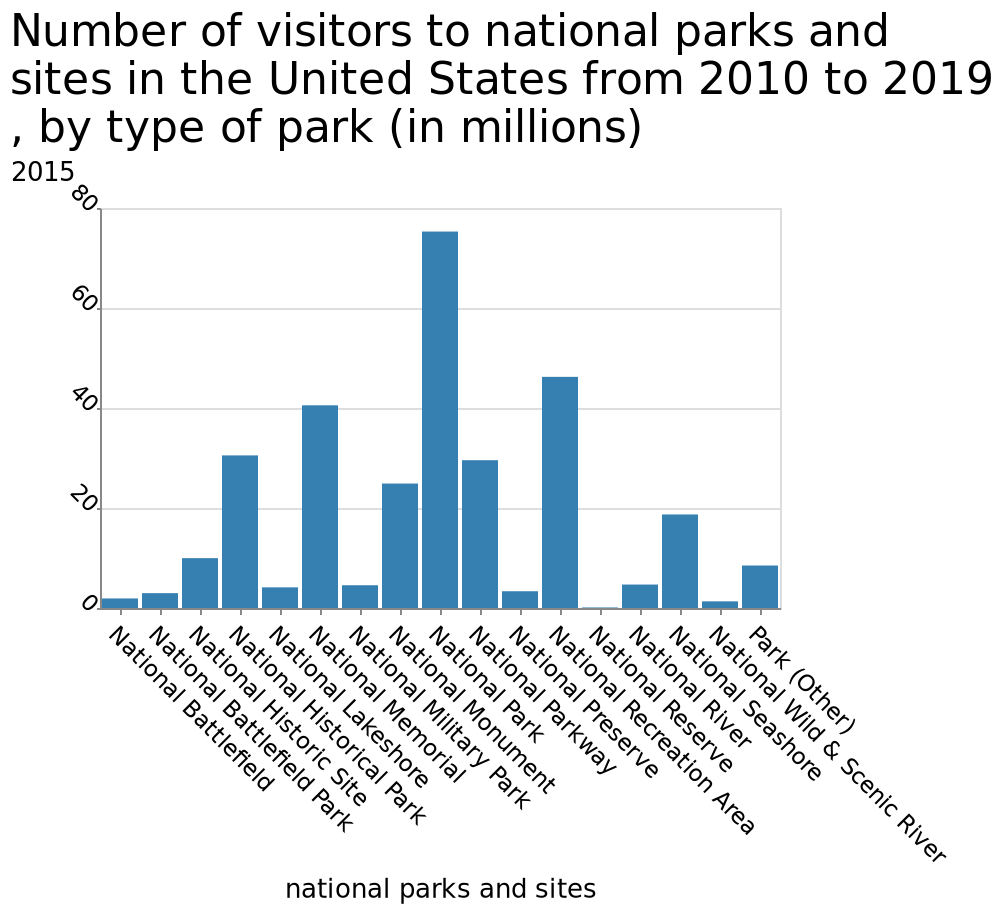<image>
please enumerates aspects of the construction of the chart Here a bar graph is titled Number of visitors to national parks and sites in the United States from 2010 to 2019 , by type of park (in millions). The x-axis shows national parks and sites on categorical scale from National Battlefield to Park (Other) while the y-axis shows 2015 as linear scale of range 0 to 80. Did any national park or reserve have more visitors than 70 million between 2010 and 2019?  No, according to the description, the national park with the highest amount of visitors had around 70 million, which was the highest amount during that period. 